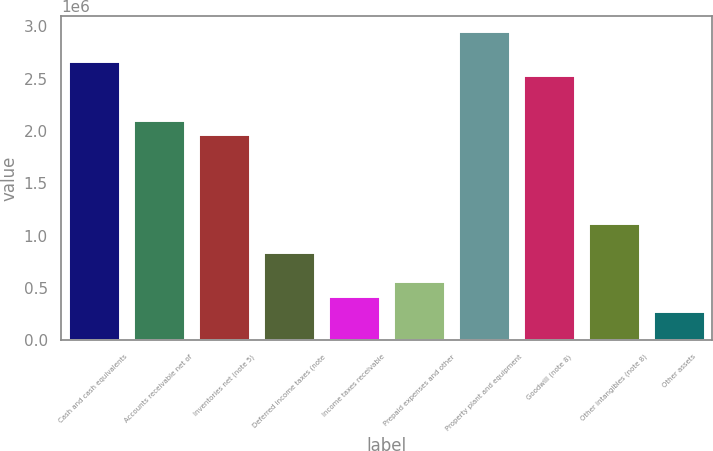Convert chart to OTSL. <chart><loc_0><loc_0><loc_500><loc_500><bar_chart><fcel>Cash and cash equivalents<fcel>Accounts receivable net of<fcel>Inventories net (note 5)<fcel>Deferred income taxes (note<fcel>Income taxes receivable<fcel>Prepaid expenses and other<fcel>Property plant and equipment<fcel>Goodwill (note 8)<fcel>Other intangibles (note 8)<fcel>Other assets<nl><fcel>2.67113e+06<fcel>2.10885e+06<fcel>1.96828e+06<fcel>843722<fcel>422013<fcel>562582<fcel>2.95227e+06<fcel>2.53056e+06<fcel>1.12486e+06<fcel>281443<nl></chart> 